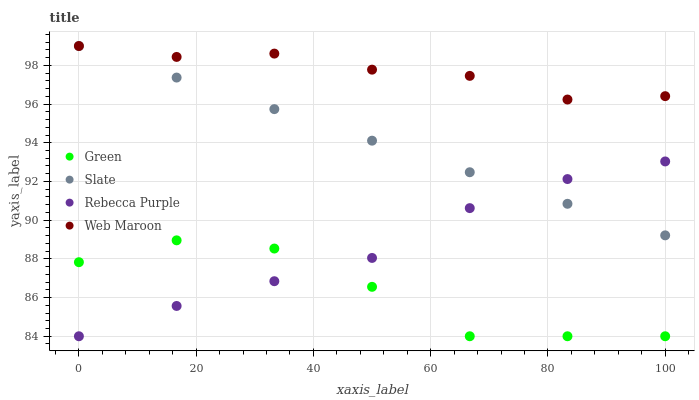Does Green have the minimum area under the curve?
Answer yes or no. Yes. Does Web Maroon have the maximum area under the curve?
Answer yes or no. Yes. Does Slate have the minimum area under the curve?
Answer yes or no. No. Does Slate have the maximum area under the curve?
Answer yes or no. No. Is Slate the smoothest?
Answer yes or no. Yes. Is Green the roughest?
Answer yes or no. Yes. Is Green the smoothest?
Answer yes or no. No. Is Slate the roughest?
Answer yes or no. No. Does Green have the lowest value?
Answer yes or no. Yes. Does Slate have the lowest value?
Answer yes or no. No. Does Slate have the highest value?
Answer yes or no. Yes. Does Green have the highest value?
Answer yes or no. No. Is Green less than Web Maroon?
Answer yes or no. Yes. Is Web Maroon greater than Green?
Answer yes or no. Yes. Does Rebecca Purple intersect Slate?
Answer yes or no. Yes. Is Rebecca Purple less than Slate?
Answer yes or no. No. Is Rebecca Purple greater than Slate?
Answer yes or no. No. Does Green intersect Web Maroon?
Answer yes or no. No. 